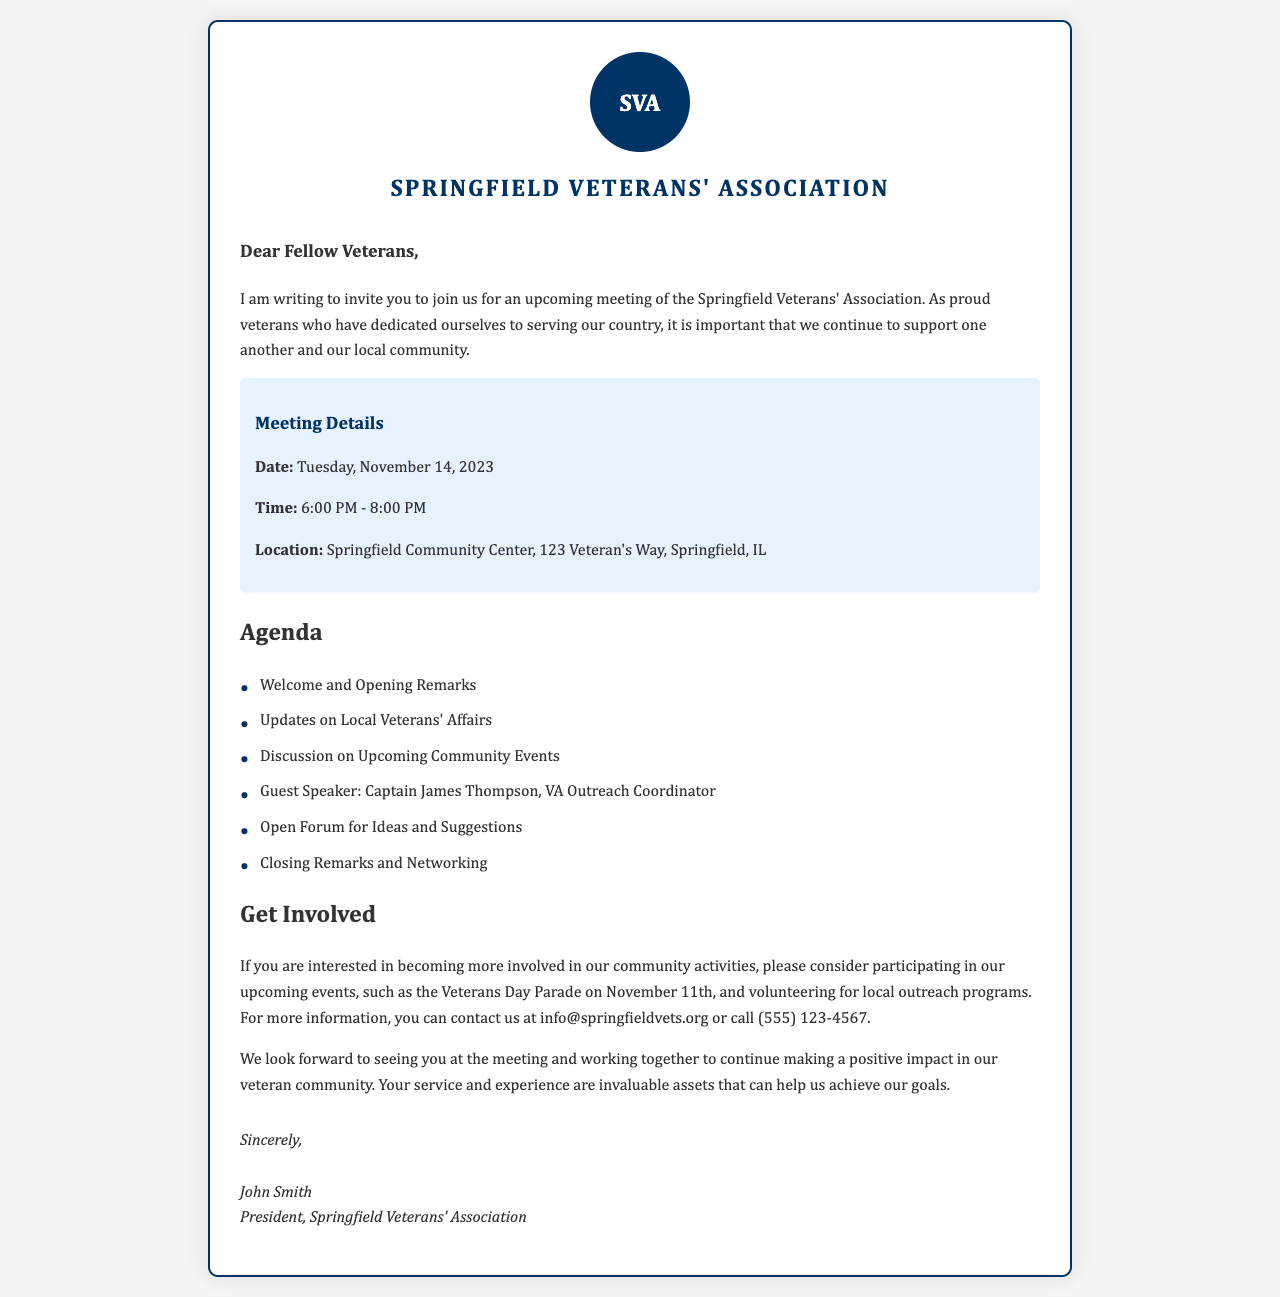What is the date of the meeting? The date is explicitly mentioned in the meeting details section of the document.
Answer: Tuesday, November 14, 2023 What time does the meeting start? The starting time is clearly stated in the meeting details.
Answer: 6:00 PM Where is the meeting location? The location is provided in the meeting details section of the document.
Answer: Springfield Community Center, 123 Veteran's Way, Springfield, IL Who is the guest speaker? The guest speaker's name is listed in the agenda section of the letter.
Answer: Captain James Thompson What event is mentioned prior to the meeting? This event is referenced as an upcoming participation opportunity in the "Get Involved" section.
Answer: Veterans Day Parade What are attendees invited to share during the meeting? This is indicated in the agenda item for discussion in the document.
Answer: Ideas and Suggestions Who is the sender of the letter? The sender's name and title are provided at the end of the document.
Answer: John Smith, President, Springfield Veterans' Association What is the primary purpose of the meeting? This can be inferred from the opening paragraph which mentions support and community.
Answer: Support one another and our local community 